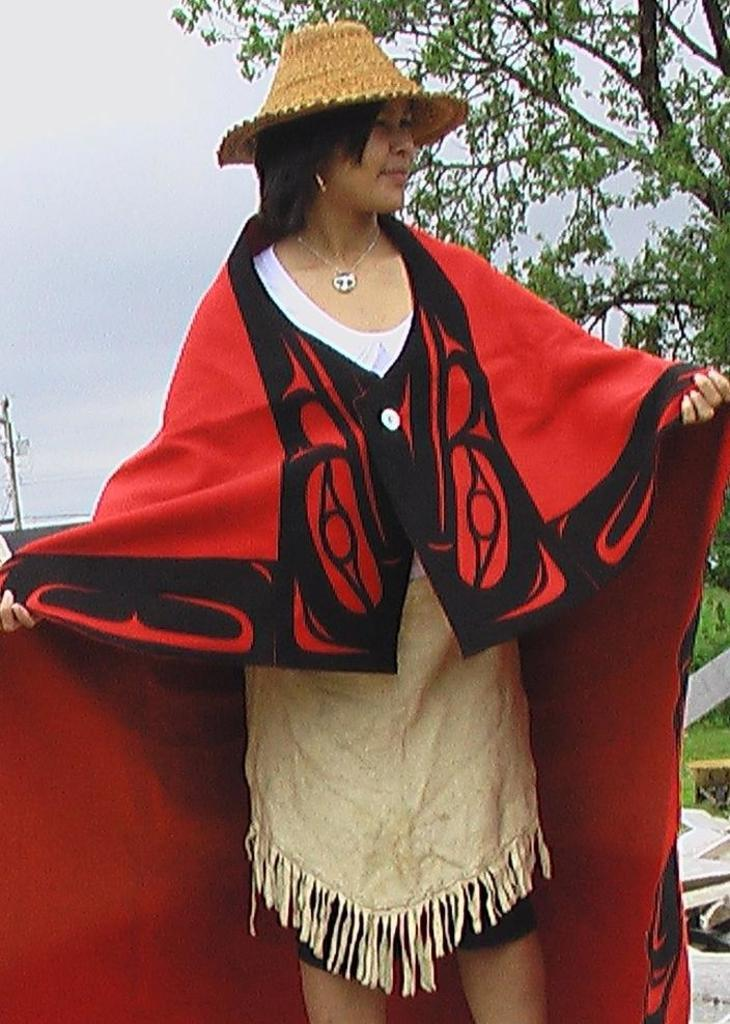Who is the main subject in the image? There is a woman in the middle of the image. What is the woman wearing on her head? The woman is wearing a hat on her head. What can be seen in the background of the image? There is a tree and the sky visible in the background of the image. What type of toothbrush is the woman using in the image? There is no toothbrush present in the image. 